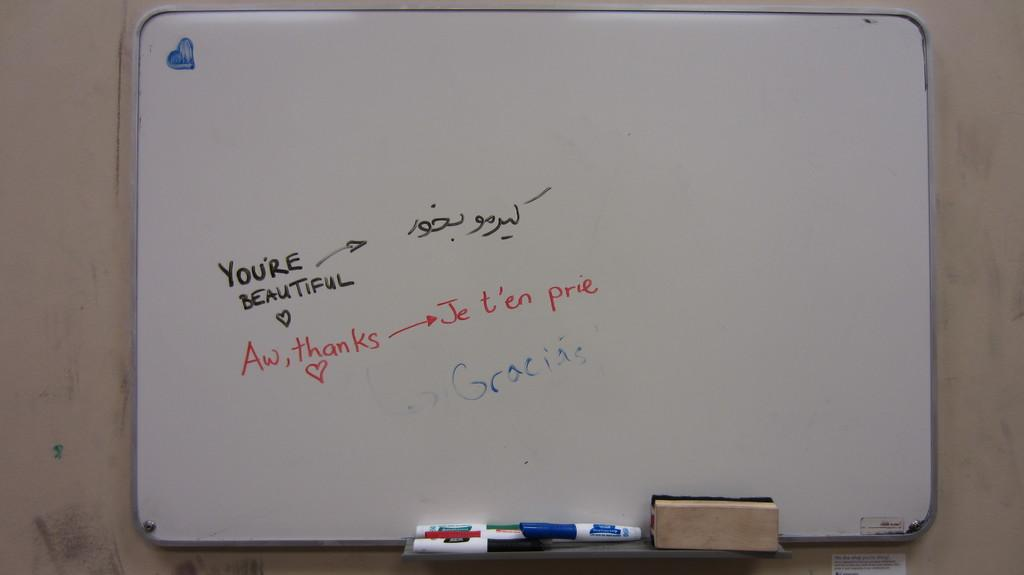<image>
Describe the image concisely. A whiteboard shows a message to someone telling them that they are beautiful. 